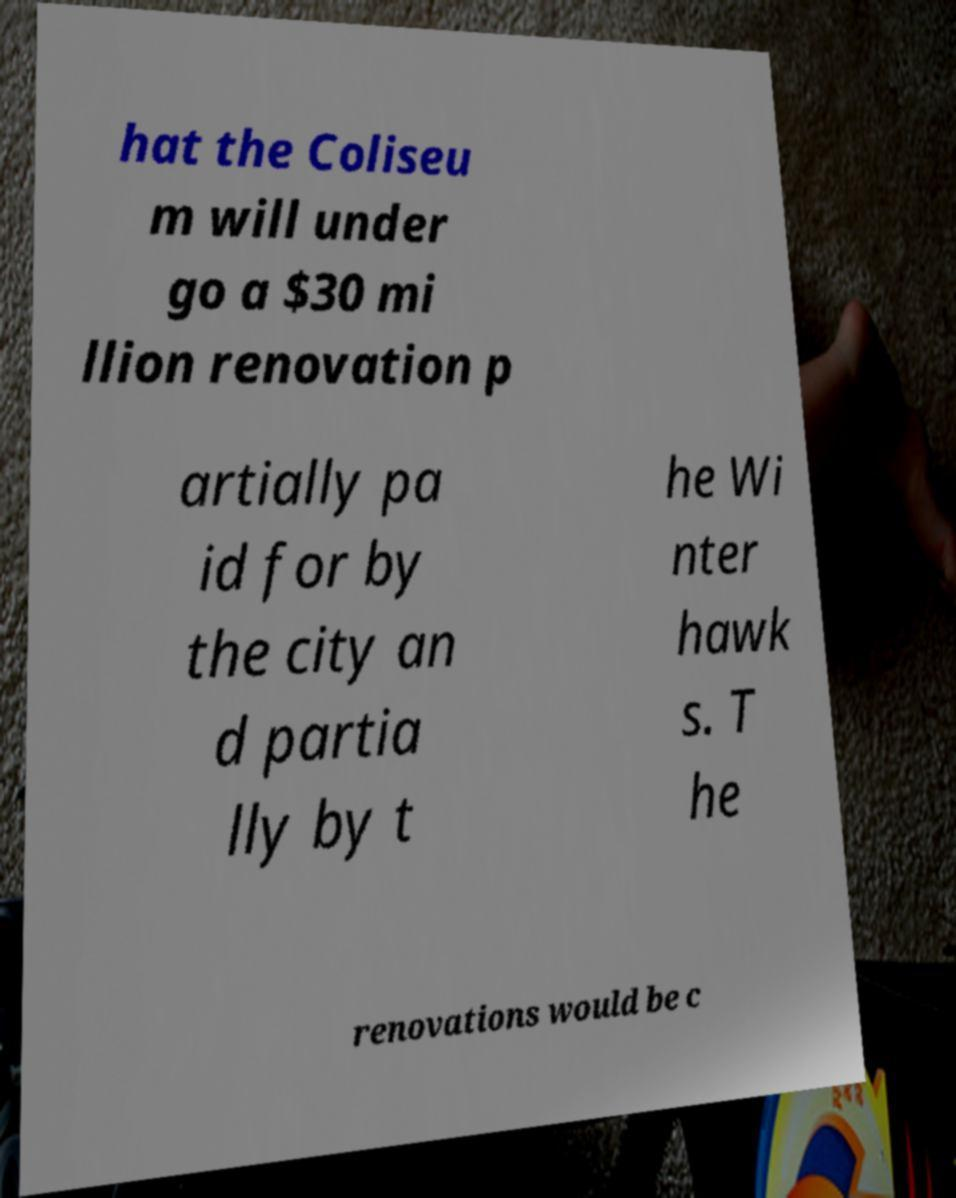Can you read and provide the text displayed in the image?This photo seems to have some interesting text. Can you extract and type it out for me? hat the Coliseu m will under go a $30 mi llion renovation p artially pa id for by the city an d partia lly by t he Wi nter hawk s. T he renovations would be c 